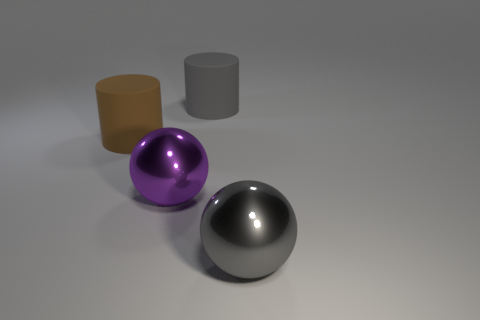Subtract all gray cylinders. Subtract all blue balls. How many cylinders are left? 1 Subtract all brown cylinders. How many cyan spheres are left? 0 Add 1 yellows. How many purples exist? 0 Subtract all big shiny objects. Subtract all big cylinders. How many objects are left? 0 Add 1 large purple metallic objects. How many large purple metallic objects are left? 2 Add 4 brown cylinders. How many brown cylinders exist? 5 Add 4 large purple objects. How many objects exist? 8 Subtract all brown cylinders. How many cylinders are left? 1 Subtract 0 brown spheres. How many objects are left? 4 Subtract 1 cylinders. How many cylinders are left? 1 